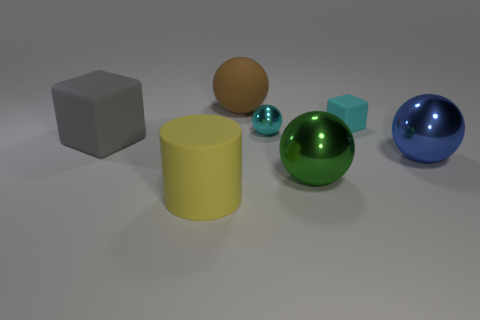There is a big thing right of the tiny thing that is behind the cyan metal object; what is its shape?
Provide a short and direct response. Sphere. What number of big objects are either purple metallic cylinders or cyan spheres?
Offer a very short reply. 0. How many big green things have the same shape as the cyan shiny thing?
Your answer should be very brief. 1. Is the shape of the green metallic object the same as the blue metallic object in front of the cyan ball?
Provide a succinct answer. Yes. How many tiny cyan spheres are behind the tiny cyan matte cube?
Keep it short and to the point. 0. Are there any brown rubber balls that have the same size as the green sphere?
Keep it short and to the point. Yes. Does the big thing that is behind the gray matte cube have the same shape as the tiny rubber thing?
Provide a short and direct response. No. What is the color of the big rubber cube?
Offer a very short reply. Gray. The tiny metallic thing that is the same color as the small rubber block is what shape?
Give a very brief answer. Sphere. Is there a big gray metal sphere?
Offer a very short reply. No. 